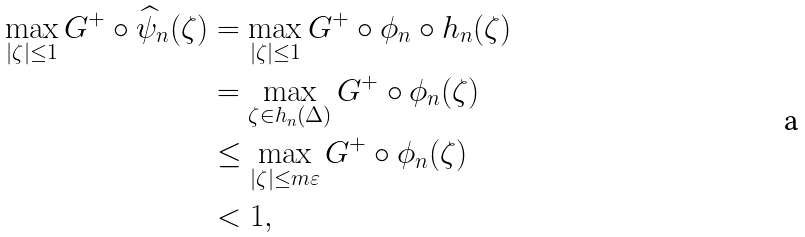Convert formula to latex. <formula><loc_0><loc_0><loc_500><loc_500>\max _ { | \zeta | \leq 1 } G ^ { + } \circ \widehat { \psi } _ { n } ( \zeta ) & = \max _ { | \zeta | \leq 1 } G ^ { + } \circ \phi _ { n } \circ h _ { n } ( \zeta ) \\ & = \max _ { \zeta \in h _ { n } ( \Delta ) } G ^ { + } \circ \phi _ { n } ( \zeta ) \\ & \leq \max _ { | \zeta | \leq m \varepsilon } G ^ { + } \circ \phi _ { n } ( \zeta ) \\ & < 1 ,</formula> 